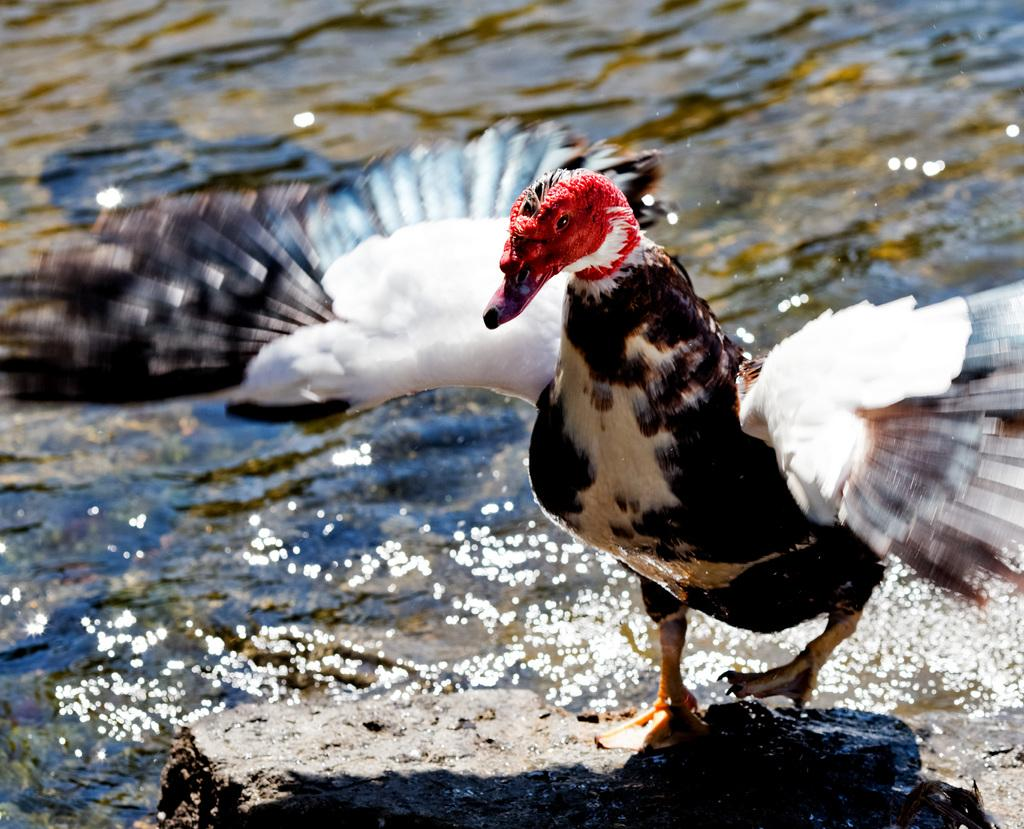What animal is present in the image? There is a duck in the image. What is the duck standing on? The duck is standing on a stone. What can be seen in the background of the image? There is water visible in the background of the image. What type of bottle is floating in the water in the image? There is no bottle present in the image; it only features a duck standing on a stone. 